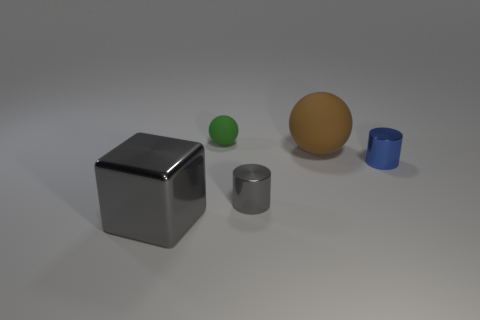What material is the object that is in front of the gray object to the right of the matte thing that is left of the small gray cylinder made of?
Provide a short and direct response. Metal. Is the size of the gray cylinder the same as the thing on the right side of the brown rubber sphere?
Make the answer very short. Yes. What material is the other green object that is the same shape as the large matte object?
Provide a succinct answer. Rubber. How big is the gray metal thing to the left of the tiny shiny cylinder that is on the left side of the tiny metallic cylinder to the right of the big brown object?
Provide a short and direct response. Large. Do the green rubber sphere and the blue cylinder have the same size?
Keep it short and to the point. Yes. The tiny thing that is behind the metal thing right of the tiny gray cylinder is made of what material?
Ensure brevity in your answer.  Rubber. There is a thing on the right side of the big brown matte sphere; does it have the same shape as the gray shiny thing that is behind the gray metal cube?
Offer a very short reply. Yes. Are there the same number of big cubes left of the shiny cube and large red rubber blocks?
Keep it short and to the point. Yes. Is there a tiny gray metal object in front of the blue shiny cylinder in front of the brown object?
Offer a very short reply. Yes. Is there anything else of the same color as the big metallic block?
Offer a terse response. Yes. 